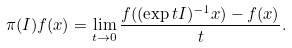Convert formula to latex. <formula><loc_0><loc_0><loc_500><loc_500>\pi ( I ) f ( x ) = \lim _ { t \to 0 } \frac { f ( ( \exp t I ) ^ { - 1 } x ) - f ( x ) } { t } .</formula> 